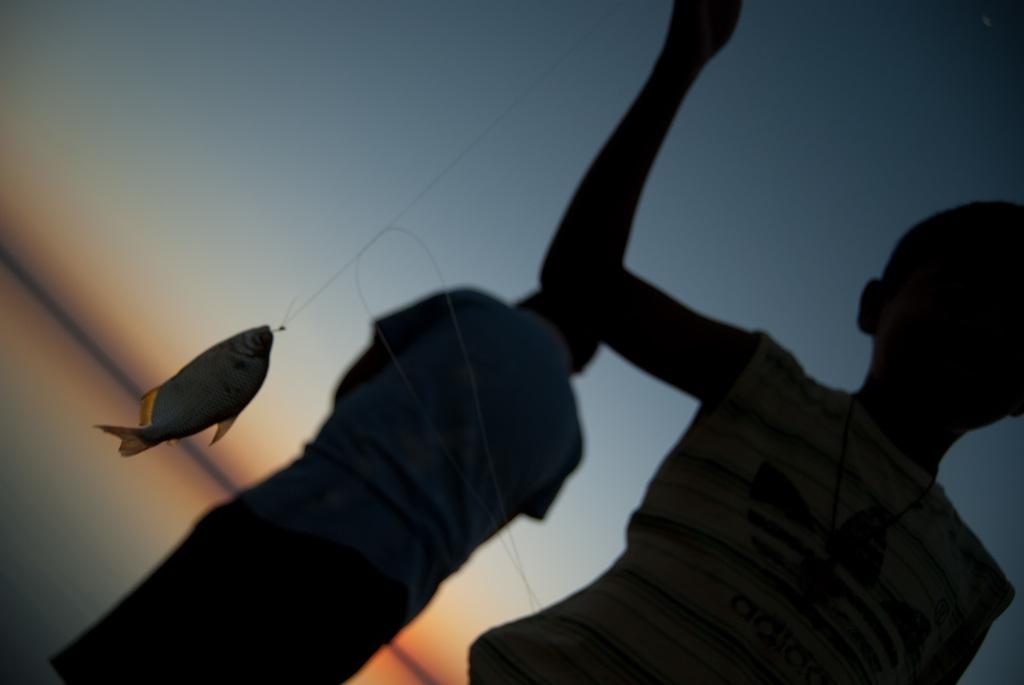Who is the main subject in the image? There is a boy in the image. What is the boy holding in the image? The boy is holding a string. What is the string connected to? The string is tied to a fish. Can you describe the other person in the image? There is another person in the background of the image. What type of ink is the boy using to write a letter to the mailbox in the image? There is no ink, letter, or mailbox present in the image. 